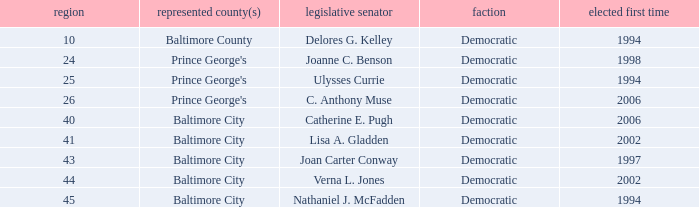Who was firest elected in 2002 in a district larger than 41? Verna L. Jones. 